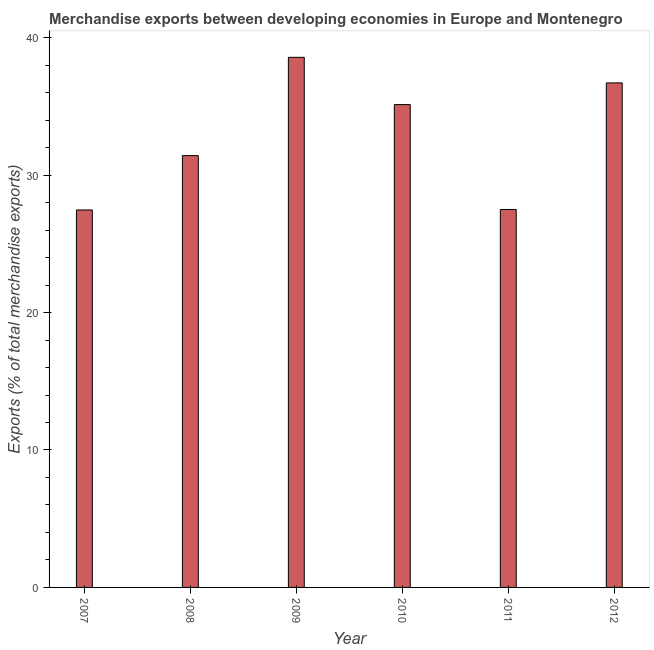Does the graph contain any zero values?
Your answer should be very brief. No. Does the graph contain grids?
Keep it short and to the point. No. What is the title of the graph?
Give a very brief answer. Merchandise exports between developing economies in Europe and Montenegro. What is the label or title of the X-axis?
Provide a short and direct response. Year. What is the label or title of the Y-axis?
Give a very brief answer. Exports (% of total merchandise exports). What is the merchandise exports in 2010?
Offer a very short reply. 35.13. Across all years, what is the maximum merchandise exports?
Provide a short and direct response. 38.57. Across all years, what is the minimum merchandise exports?
Keep it short and to the point. 27.46. What is the sum of the merchandise exports?
Give a very brief answer. 196.78. What is the difference between the merchandise exports in 2011 and 2012?
Give a very brief answer. -9.21. What is the average merchandise exports per year?
Your answer should be compact. 32.8. What is the median merchandise exports?
Offer a very short reply. 33.27. Do a majority of the years between 2010 and 2012 (inclusive) have merchandise exports greater than 4 %?
Make the answer very short. Yes. What is the ratio of the merchandise exports in 2008 to that in 2009?
Give a very brief answer. 0.81. Is the difference between the merchandise exports in 2009 and 2012 greater than the difference between any two years?
Make the answer very short. No. What is the difference between the highest and the second highest merchandise exports?
Your answer should be compact. 1.86. What is the difference between the highest and the lowest merchandise exports?
Keep it short and to the point. 11.11. In how many years, is the merchandise exports greater than the average merchandise exports taken over all years?
Provide a short and direct response. 3. How many bars are there?
Provide a succinct answer. 6. Are all the bars in the graph horizontal?
Offer a very short reply. No. How many years are there in the graph?
Make the answer very short. 6. What is the difference between two consecutive major ticks on the Y-axis?
Your answer should be very brief. 10. What is the Exports (% of total merchandise exports) of 2007?
Offer a very short reply. 27.46. What is the Exports (% of total merchandise exports) in 2008?
Give a very brief answer. 31.42. What is the Exports (% of total merchandise exports) in 2009?
Offer a terse response. 38.57. What is the Exports (% of total merchandise exports) in 2010?
Provide a succinct answer. 35.13. What is the Exports (% of total merchandise exports) of 2011?
Give a very brief answer. 27.5. What is the Exports (% of total merchandise exports) of 2012?
Your response must be concise. 36.71. What is the difference between the Exports (% of total merchandise exports) in 2007 and 2008?
Offer a very short reply. -3.95. What is the difference between the Exports (% of total merchandise exports) in 2007 and 2009?
Provide a succinct answer. -11.11. What is the difference between the Exports (% of total merchandise exports) in 2007 and 2010?
Provide a short and direct response. -7.67. What is the difference between the Exports (% of total merchandise exports) in 2007 and 2011?
Offer a very short reply. -0.03. What is the difference between the Exports (% of total merchandise exports) in 2007 and 2012?
Your answer should be very brief. -9.24. What is the difference between the Exports (% of total merchandise exports) in 2008 and 2009?
Ensure brevity in your answer.  -7.15. What is the difference between the Exports (% of total merchandise exports) in 2008 and 2010?
Ensure brevity in your answer.  -3.71. What is the difference between the Exports (% of total merchandise exports) in 2008 and 2011?
Provide a succinct answer. 3.92. What is the difference between the Exports (% of total merchandise exports) in 2008 and 2012?
Ensure brevity in your answer.  -5.29. What is the difference between the Exports (% of total merchandise exports) in 2009 and 2010?
Your answer should be compact. 3.44. What is the difference between the Exports (% of total merchandise exports) in 2009 and 2011?
Offer a very short reply. 11.07. What is the difference between the Exports (% of total merchandise exports) in 2009 and 2012?
Your answer should be compact. 1.86. What is the difference between the Exports (% of total merchandise exports) in 2010 and 2011?
Provide a succinct answer. 7.63. What is the difference between the Exports (% of total merchandise exports) in 2010 and 2012?
Your answer should be very brief. -1.58. What is the difference between the Exports (% of total merchandise exports) in 2011 and 2012?
Your answer should be very brief. -9.21. What is the ratio of the Exports (% of total merchandise exports) in 2007 to that in 2008?
Ensure brevity in your answer.  0.87. What is the ratio of the Exports (% of total merchandise exports) in 2007 to that in 2009?
Provide a short and direct response. 0.71. What is the ratio of the Exports (% of total merchandise exports) in 2007 to that in 2010?
Make the answer very short. 0.78. What is the ratio of the Exports (% of total merchandise exports) in 2007 to that in 2011?
Offer a very short reply. 1. What is the ratio of the Exports (% of total merchandise exports) in 2007 to that in 2012?
Offer a very short reply. 0.75. What is the ratio of the Exports (% of total merchandise exports) in 2008 to that in 2009?
Your answer should be compact. 0.81. What is the ratio of the Exports (% of total merchandise exports) in 2008 to that in 2010?
Ensure brevity in your answer.  0.89. What is the ratio of the Exports (% of total merchandise exports) in 2008 to that in 2011?
Make the answer very short. 1.14. What is the ratio of the Exports (% of total merchandise exports) in 2008 to that in 2012?
Keep it short and to the point. 0.86. What is the ratio of the Exports (% of total merchandise exports) in 2009 to that in 2010?
Your answer should be compact. 1.1. What is the ratio of the Exports (% of total merchandise exports) in 2009 to that in 2011?
Your response must be concise. 1.4. What is the ratio of the Exports (% of total merchandise exports) in 2009 to that in 2012?
Provide a succinct answer. 1.05. What is the ratio of the Exports (% of total merchandise exports) in 2010 to that in 2011?
Keep it short and to the point. 1.28. What is the ratio of the Exports (% of total merchandise exports) in 2011 to that in 2012?
Provide a succinct answer. 0.75. 